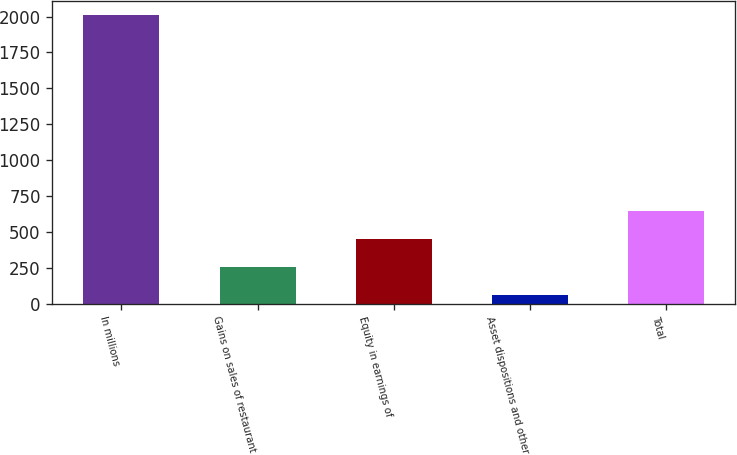Convert chart. <chart><loc_0><loc_0><loc_500><loc_500><bar_chart><fcel>In millions<fcel>Gains on sales of restaurant<fcel>Equity in earnings of<fcel>Asset dispositions and other<fcel>Total<nl><fcel>2009<fcel>253.82<fcel>448.84<fcel>58.8<fcel>643.86<nl></chart> 